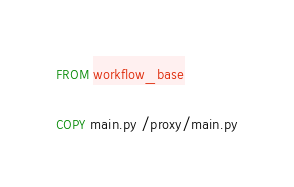<code> <loc_0><loc_0><loc_500><loc_500><_Dockerfile_>FROM workflow_base

COPY main.py /proxy/main.py
</code> 